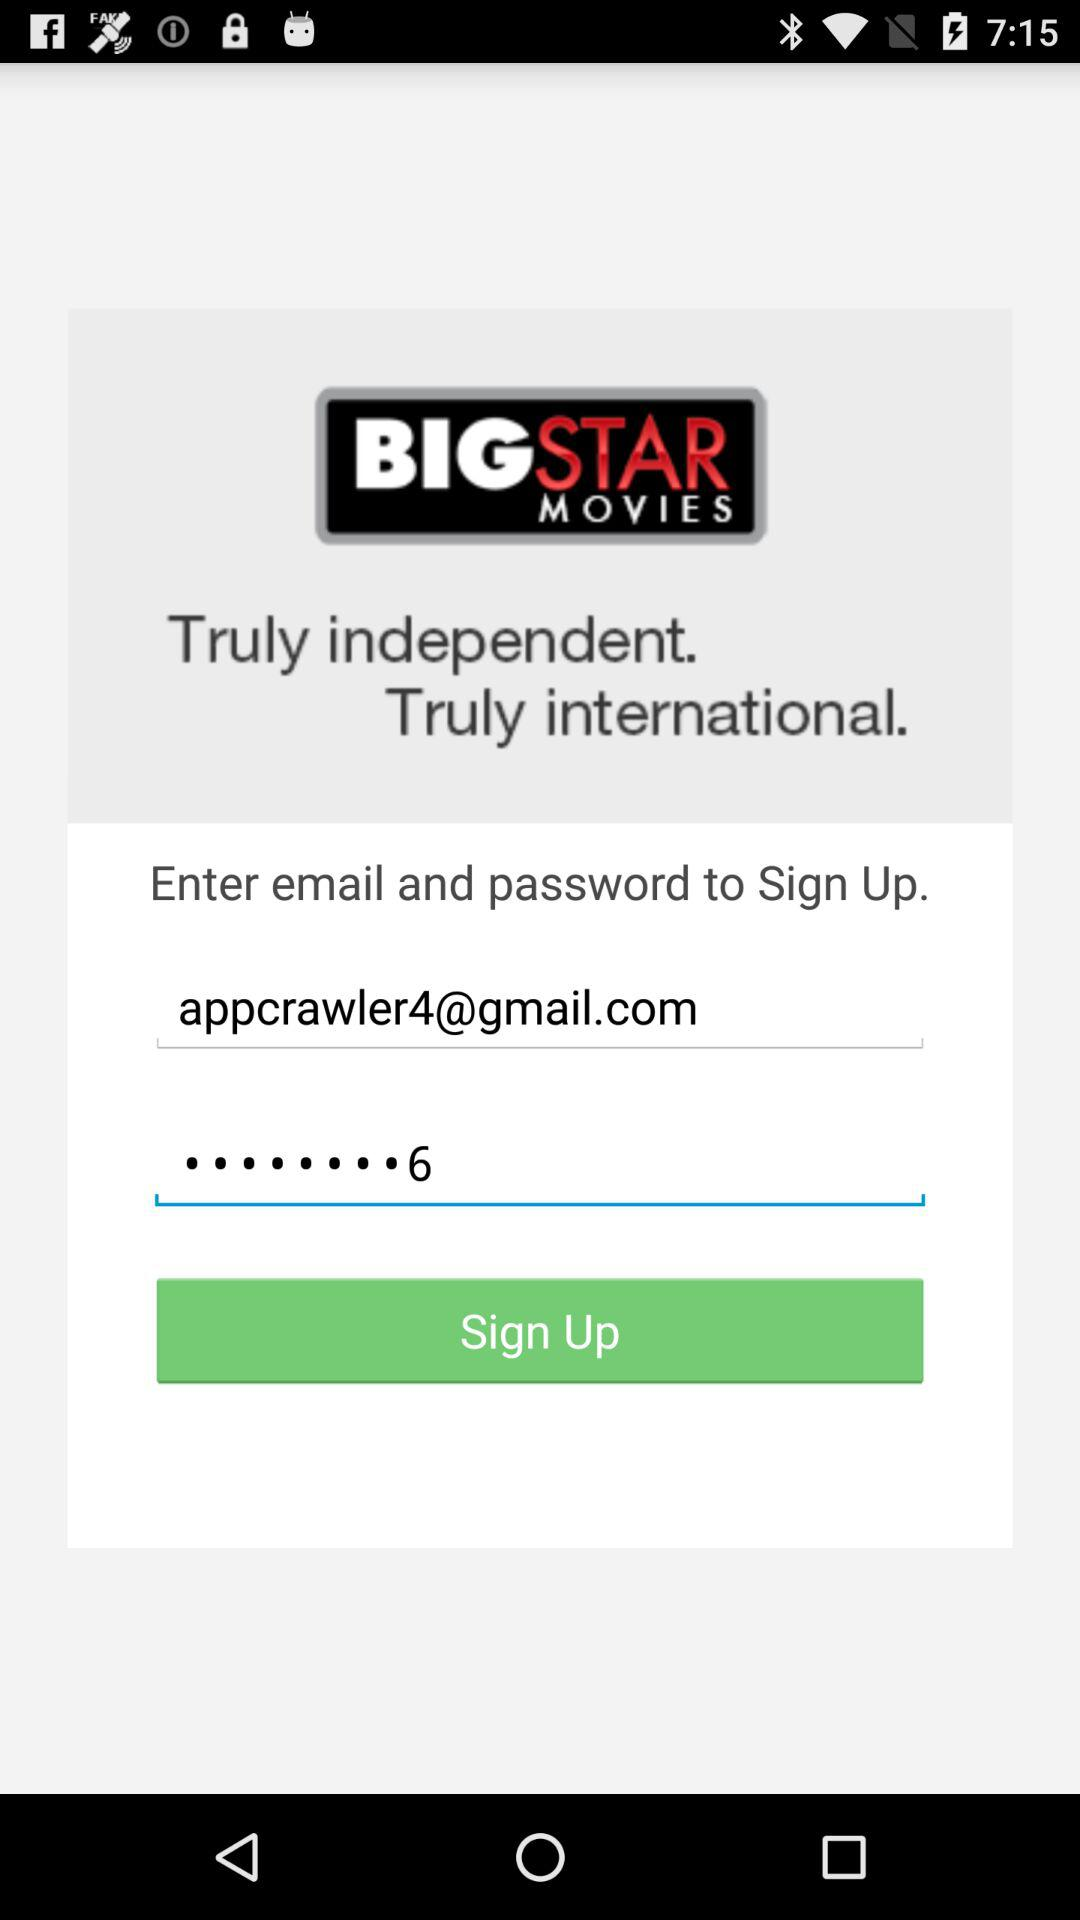What is the last digit of the password? The last digit of the password is 6. 